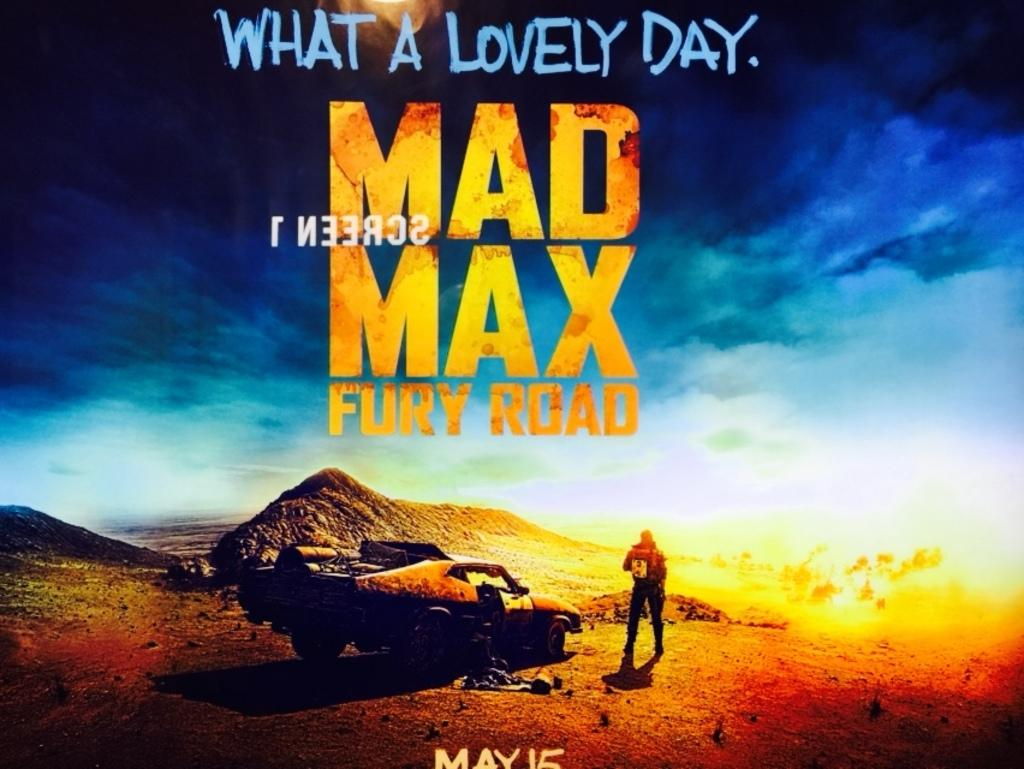<image>
Render a clear and concise summary of the photo. A Mad Max Fury Road poster with a car and man in the desert. 